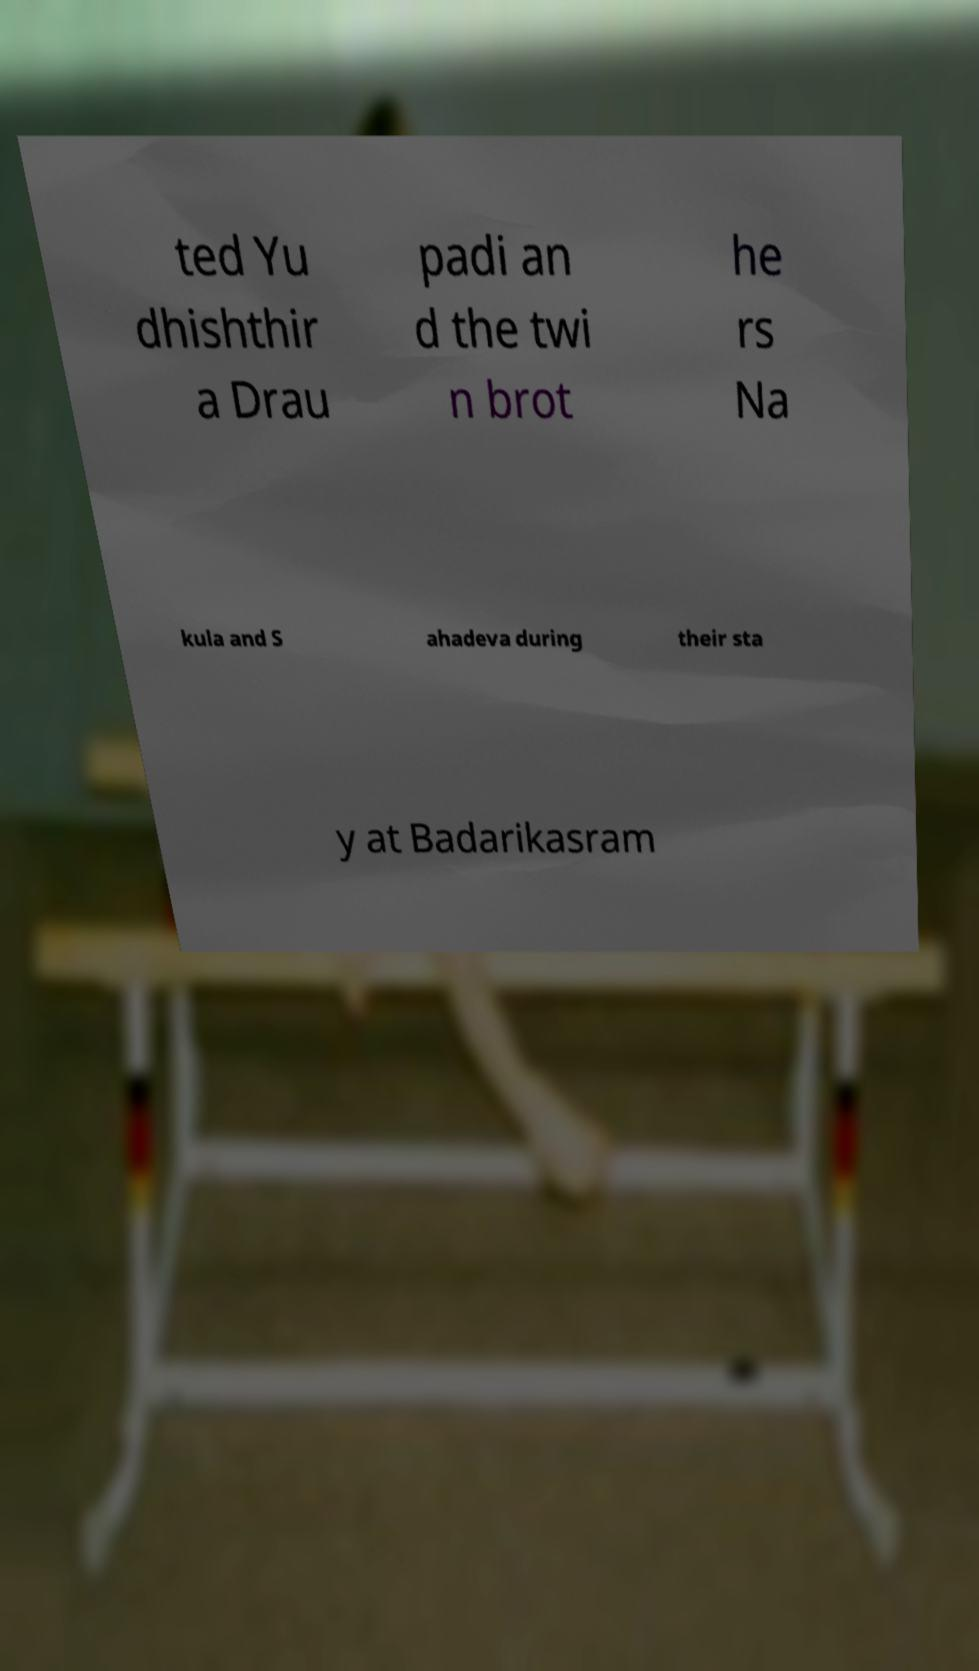Could you assist in decoding the text presented in this image and type it out clearly? ted Yu dhishthir a Drau padi an d the twi n brot he rs Na kula and S ahadeva during their sta y at Badarikasram 